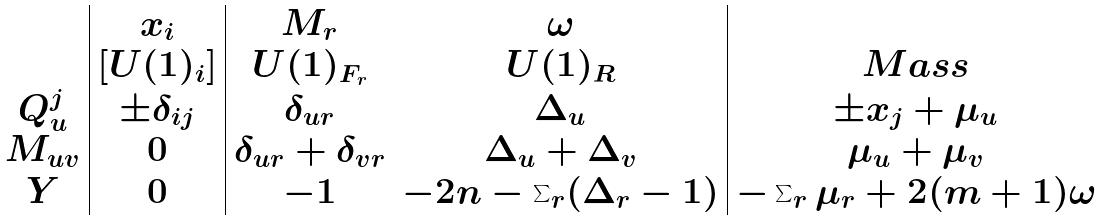<formula> <loc_0><loc_0><loc_500><loc_500>\begin{array} { c | c | c c | c } & x _ { i } & M _ { r } & \omega & \\ & [ U ( 1 ) _ { i } ] & U ( 1 ) _ { F _ { r } } & U ( 1 ) _ { R } & M a s s \\ Q ^ { j } _ { u } & \pm \delta _ { i j } & \delta _ { u r } & \Delta _ { u } & \pm x _ { j } + \mu _ { u } \\ M _ { u v } & 0 & \delta _ { u r } + \delta _ { v r } & \Delta _ { u } + \Delta _ { v } & \mu _ { u } + \mu _ { v } \\ Y & 0 & - 1 & - 2 n - \sum _ { r } ( \Delta _ { r } - 1 ) & - \sum _ { r } \mu _ { r } + 2 ( m + 1 ) \omega \end{array}</formula> 